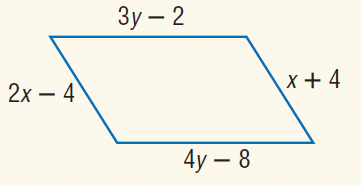Answer the mathemtical geometry problem and directly provide the correct option letter.
Question: Find y so that the quadrilateral is a parallelogram.
Choices: A: 2 B: 3 C: 6 D: 12 C 